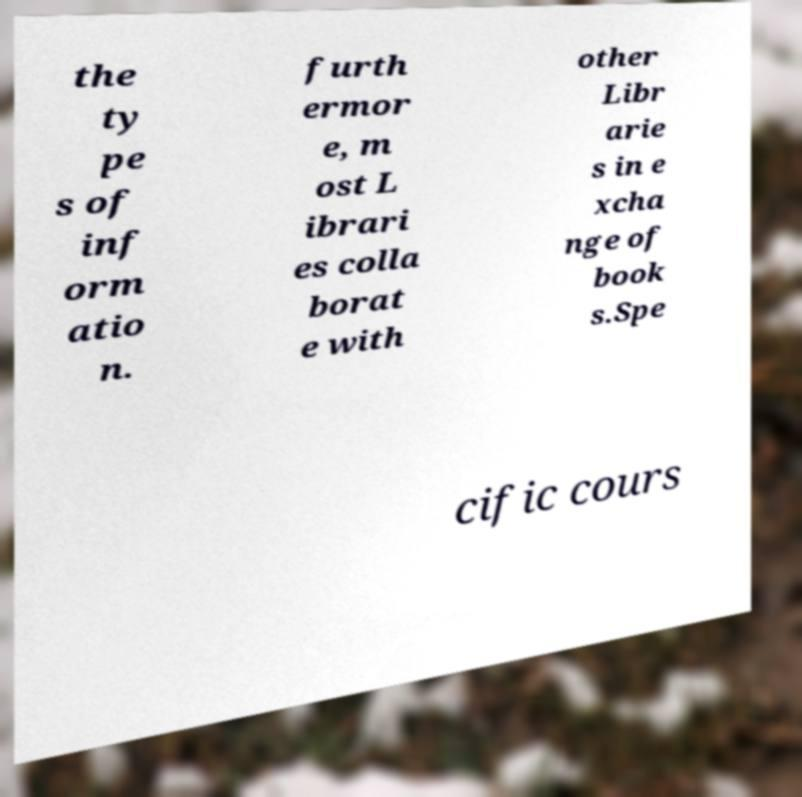Could you extract and type out the text from this image? the ty pe s of inf orm atio n. furth ermor e, m ost L ibrari es colla borat e with other Libr arie s in e xcha nge of book s.Spe cific cours 